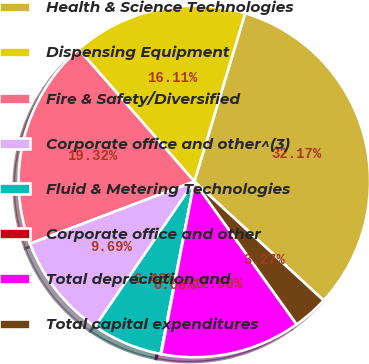Convert chart to OTSL. <chart><loc_0><loc_0><loc_500><loc_500><pie_chart><fcel>Health & Science Technologies<fcel>Dispensing Equipment<fcel>Fire & Safety/Diversified<fcel>Corporate office and other^(3)<fcel>Fluid & Metering Technologies<fcel>Corporate office and other<fcel>Total depreciation and<fcel>Total capital expenditures<nl><fcel>32.17%<fcel>16.11%<fcel>19.32%<fcel>9.69%<fcel>6.48%<fcel>0.06%<fcel>12.9%<fcel>3.27%<nl></chart> 